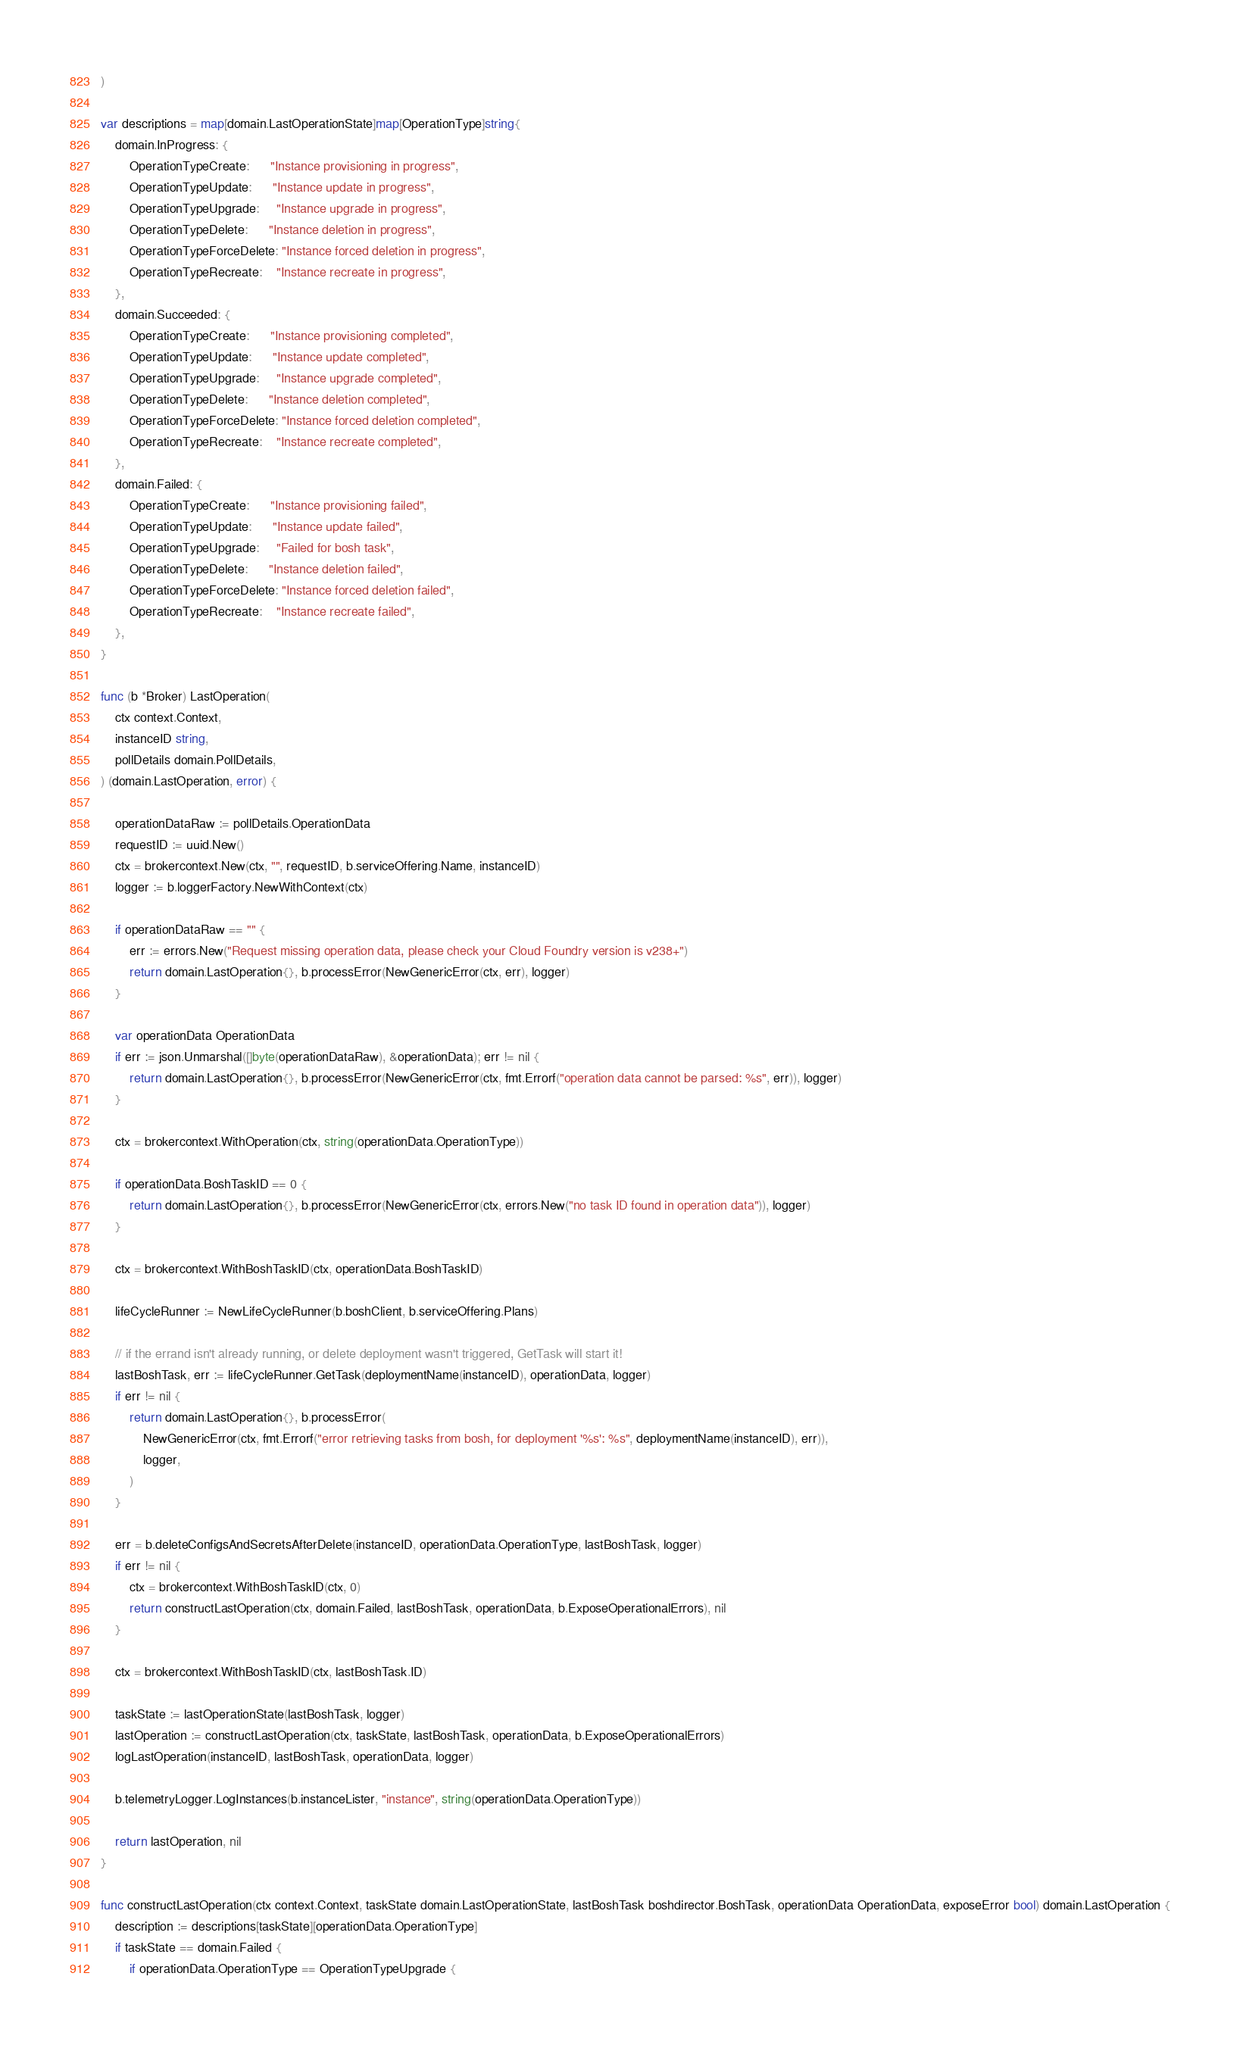<code> <loc_0><loc_0><loc_500><loc_500><_Go_>)

var descriptions = map[domain.LastOperationState]map[OperationType]string{
	domain.InProgress: {
		OperationTypeCreate:      "Instance provisioning in progress",
		OperationTypeUpdate:      "Instance update in progress",
		OperationTypeUpgrade:     "Instance upgrade in progress",
		OperationTypeDelete:      "Instance deletion in progress",
		OperationTypeForceDelete: "Instance forced deletion in progress",
		OperationTypeRecreate:    "Instance recreate in progress",
	},
	domain.Succeeded: {
		OperationTypeCreate:      "Instance provisioning completed",
		OperationTypeUpdate:      "Instance update completed",
		OperationTypeUpgrade:     "Instance upgrade completed",
		OperationTypeDelete:      "Instance deletion completed",
		OperationTypeForceDelete: "Instance forced deletion completed",
		OperationTypeRecreate:    "Instance recreate completed",
	},
	domain.Failed: {
		OperationTypeCreate:      "Instance provisioning failed",
		OperationTypeUpdate:      "Instance update failed",
		OperationTypeUpgrade:     "Failed for bosh task",
		OperationTypeDelete:      "Instance deletion failed",
		OperationTypeForceDelete: "Instance forced deletion failed",
		OperationTypeRecreate:    "Instance recreate failed",
	},
}

func (b *Broker) LastOperation(
	ctx context.Context,
	instanceID string,
	pollDetails domain.PollDetails,
) (domain.LastOperation, error) {

	operationDataRaw := pollDetails.OperationData
	requestID := uuid.New()
	ctx = brokercontext.New(ctx, "", requestID, b.serviceOffering.Name, instanceID)
	logger := b.loggerFactory.NewWithContext(ctx)

	if operationDataRaw == "" {
		err := errors.New("Request missing operation data, please check your Cloud Foundry version is v238+")
		return domain.LastOperation{}, b.processError(NewGenericError(ctx, err), logger)
	}

	var operationData OperationData
	if err := json.Unmarshal([]byte(operationDataRaw), &operationData); err != nil {
		return domain.LastOperation{}, b.processError(NewGenericError(ctx, fmt.Errorf("operation data cannot be parsed: %s", err)), logger)
	}

	ctx = brokercontext.WithOperation(ctx, string(operationData.OperationType))

	if operationData.BoshTaskID == 0 {
		return domain.LastOperation{}, b.processError(NewGenericError(ctx, errors.New("no task ID found in operation data")), logger)
	}

	ctx = brokercontext.WithBoshTaskID(ctx, operationData.BoshTaskID)

	lifeCycleRunner := NewLifeCycleRunner(b.boshClient, b.serviceOffering.Plans)

	// if the errand isn't already running, or delete deployment wasn't triggered, GetTask will start it!
	lastBoshTask, err := lifeCycleRunner.GetTask(deploymentName(instanceID), operationData, logger)
	if err != nil {
		return domain.LastOperation{}, b.processError(
			NewGenericError(ctx, fmt.Errorf("error retrieving tasks from bosh, for deployment '%s': %s", deploymentName(instanceID), err)),
			logger,
		)
	}

	err = b.deleteConfigsAndSecretsAfterDelete(instanceID, operationData.OperationType, lastBoshTask, logger)
	if err != nil {
		ctx = brokercontext.WithBoshTaskID(ctx, 0)
		return constructLastOperation(ctx, domain.Failed, lastBoshTask, operationData, b.ExposeOperationalErrors), nil
	}

	ctx = brokercontext.WithBoshTaskID(ctx, lastBoshTask.ID)

	taskState := lastOperationState(lastBoshTask, logger)
	lastOperation := constructLastOperation(ctx, taskState, lastBoshTask, operationData, b.ExposeOperationalErrors)
	logLastOperation(instanceID, lastBoshTask, operationData, logger)

	b.telemetryLogger.LogInstances(b.instanceLister, "instance", string(operationData.OperationType))

	return lastOperation, nil
}

func constructLastOperation(ctx context.Context, taskState domain.LastOperationState, lastBoshTask boshdirector.BoshTask, operationData OperationData, exposeError bool) domain.LastOperation {
	description := descriptions[taskState][operationData.OperationType]
	if taskState == domain.Failed {
		if operationData.OperationType == OperationTypeUpgrade {</code> 